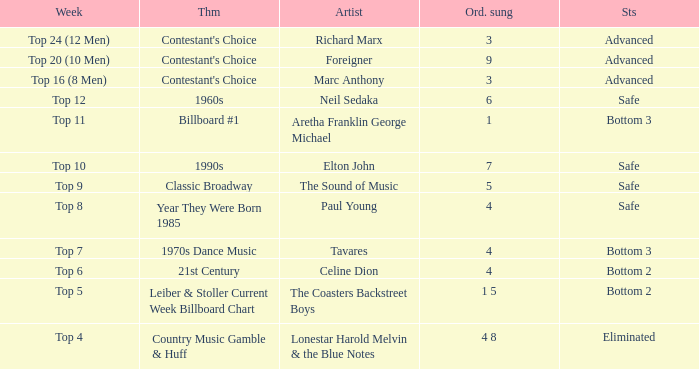What artist's song was performed in the week with theme of Billboard #1? Aretha Franklin George Michael. 